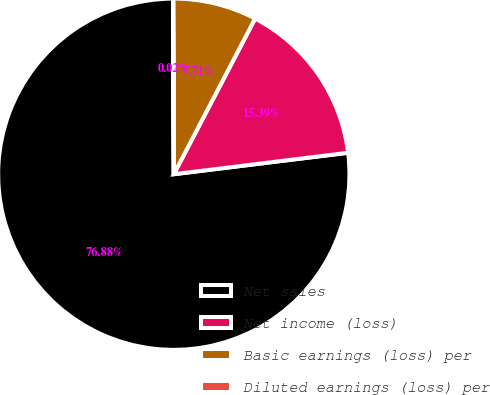Convert chart to OTSL. <chart><loc_0><loc_0><loc_500><loc_500><pie_chart><fcel>Net sales<fcel>Net income (loss)<fcel>Basic earnings (loss) per<fcel>Diluted earnings (loss) per<nl><fcel>76.88%<fcel>15.39%<fcel>7.71%<fcel>0.02%<nl></chart> 